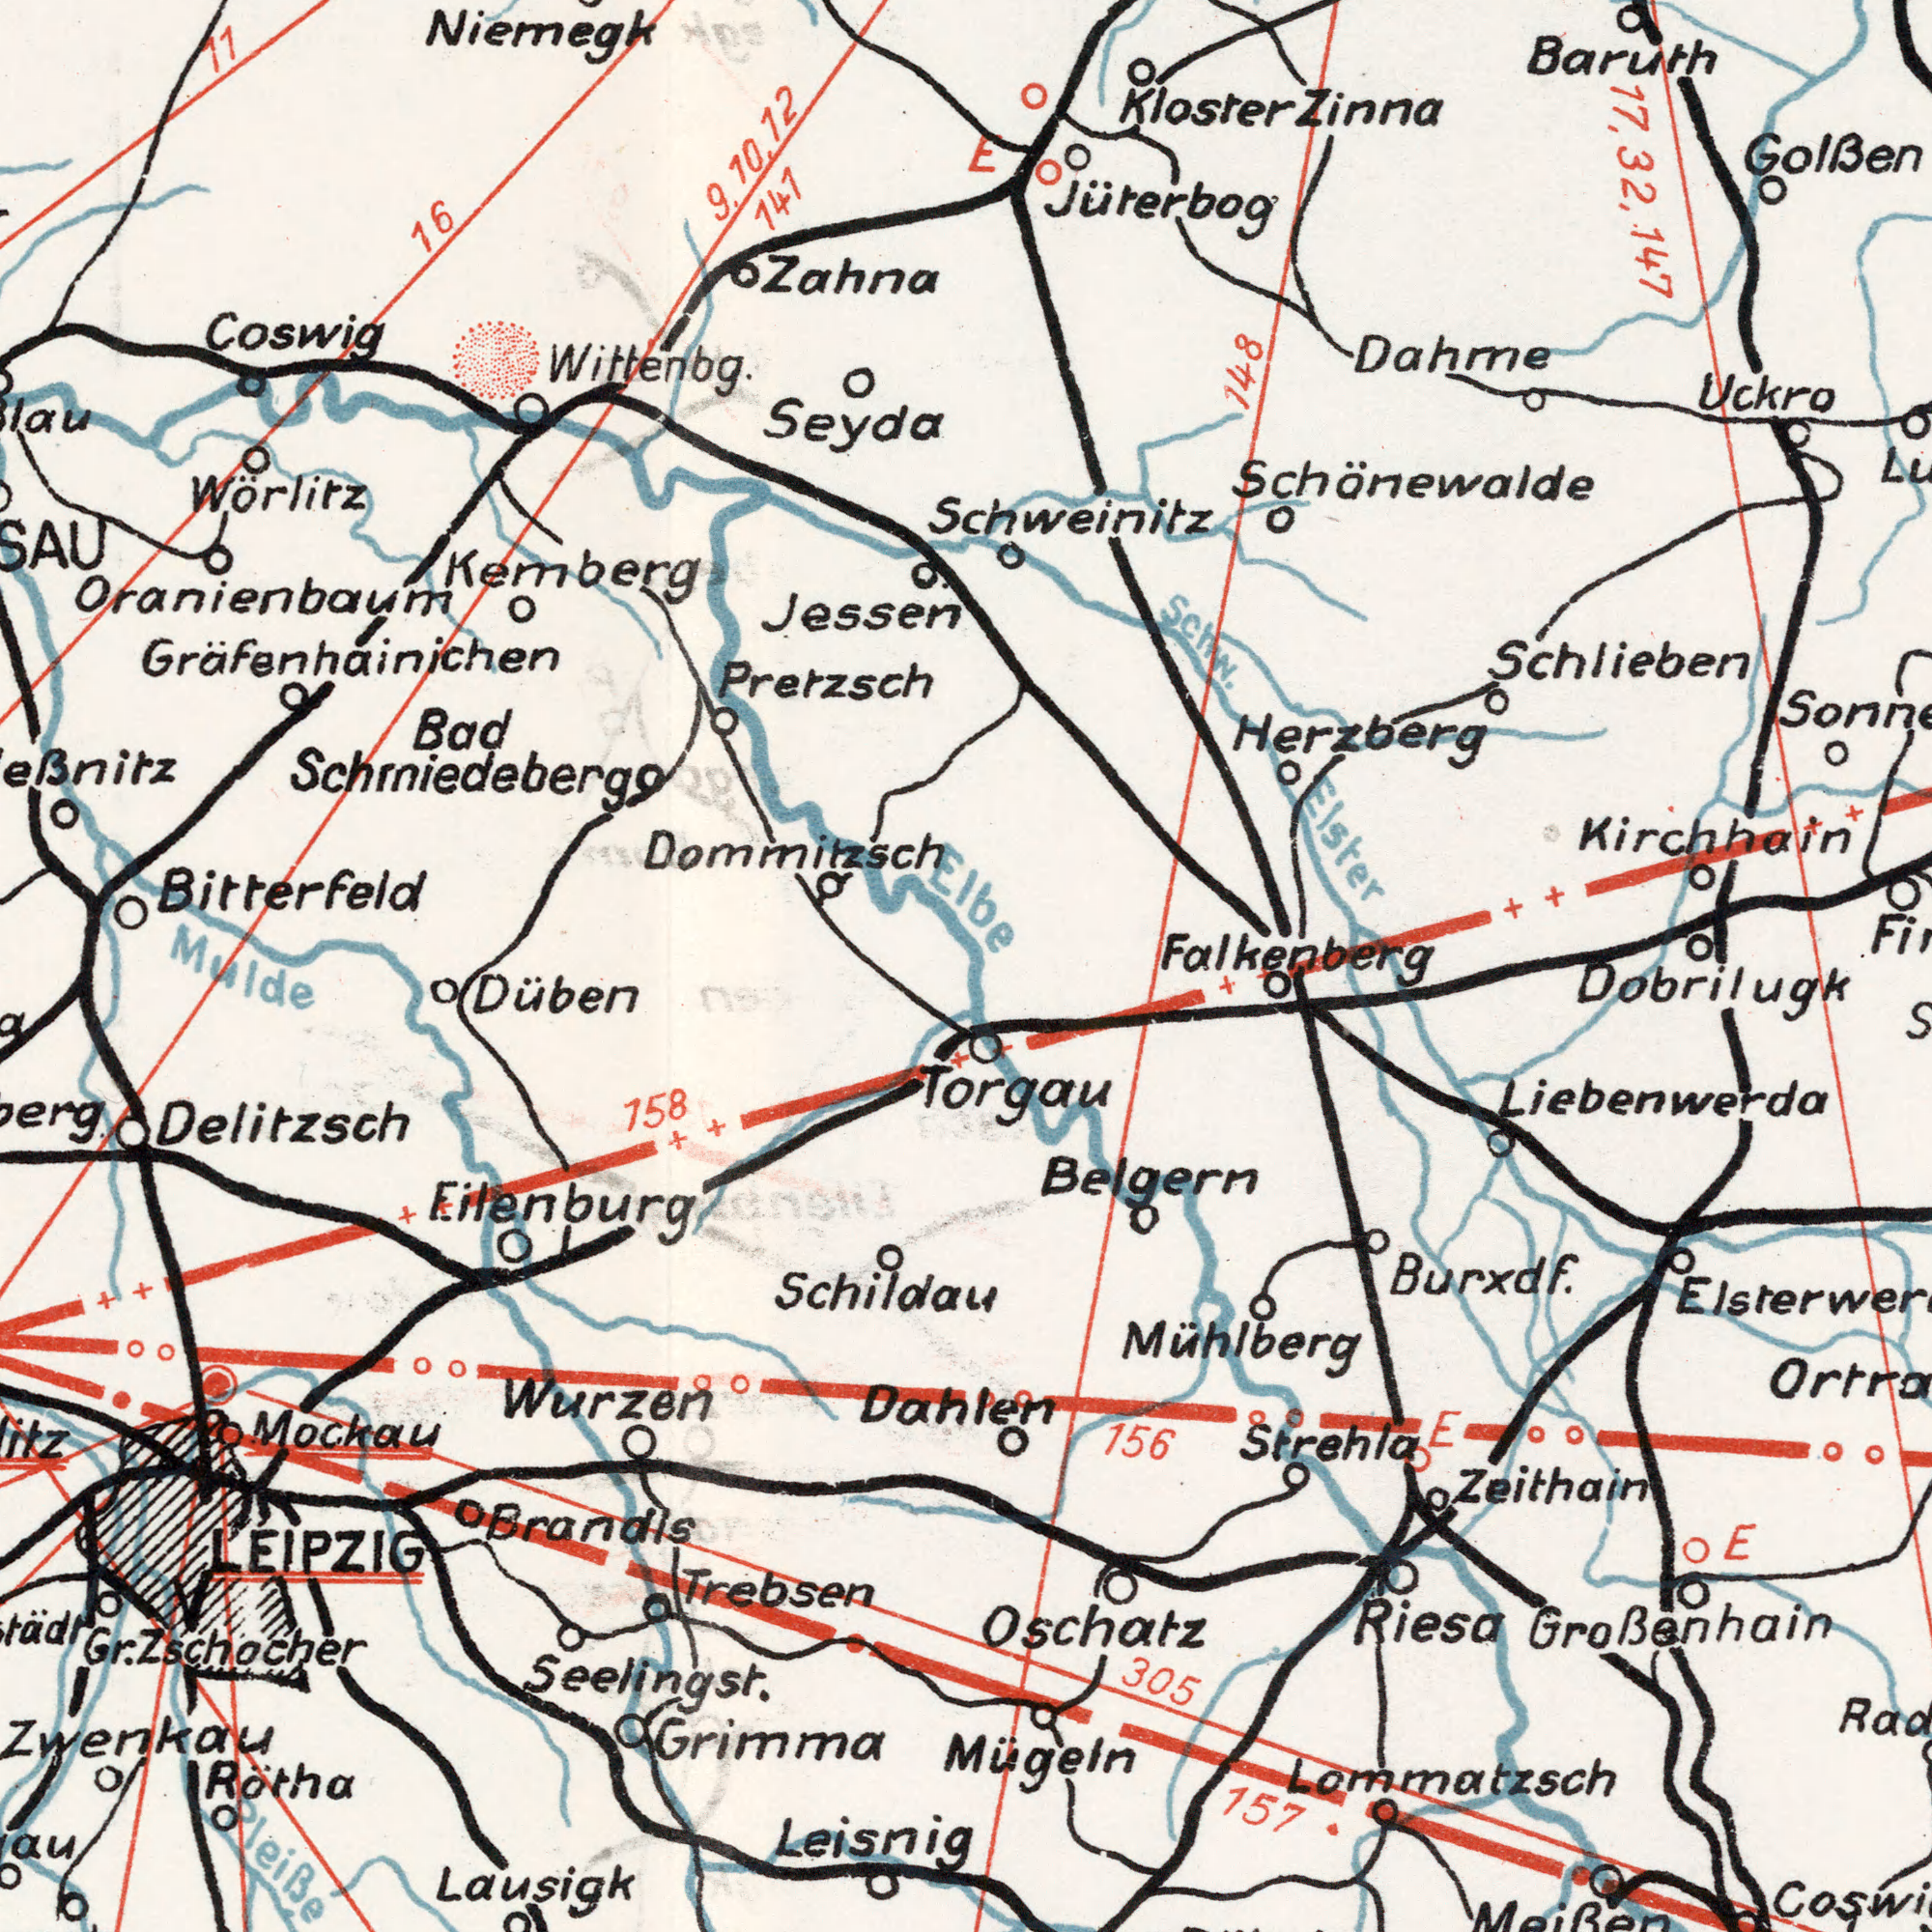What text is visible in the lower-right corner? Mühlberg Oschatz Burxdf. Strehla Dobrilugk 156 157 Lommatzsch Großenhain Riesa Belgern 305 Zeithain Liebenwerda E Mügeln Torgau E Meißen What text is visible in the upper-left corner? Wörlitz Kemberg Wittenbg. Seyda Coswig Jessen Bad Zahna 11 Dommitzsch 16 Pretzsch 141 Oranienbaum Schmiedeberg Gräfenhainichen Niemegk Bitterfeld 9, 10 12 What text can you see in the top-right section? Schlieben Uckro Golßen Jüterbog Dahme Herzberg Schw. Baruth 17, Elster Falkenberg 147 32, 148 Fi## Schweinitz Kirchhain Schönewalde Zinna E Kloster Elbe What text appears in the bottom-left area of the image? Delitzsch Grimma Lausigk Wurzen Brandis Schildau Trebsen Leisnig 158 Düben Rötha Eilenburg Pleiße Gr. LEIPZIG Zwenkau Mockau Mulde Dahlen Zschocher Seeling St. 